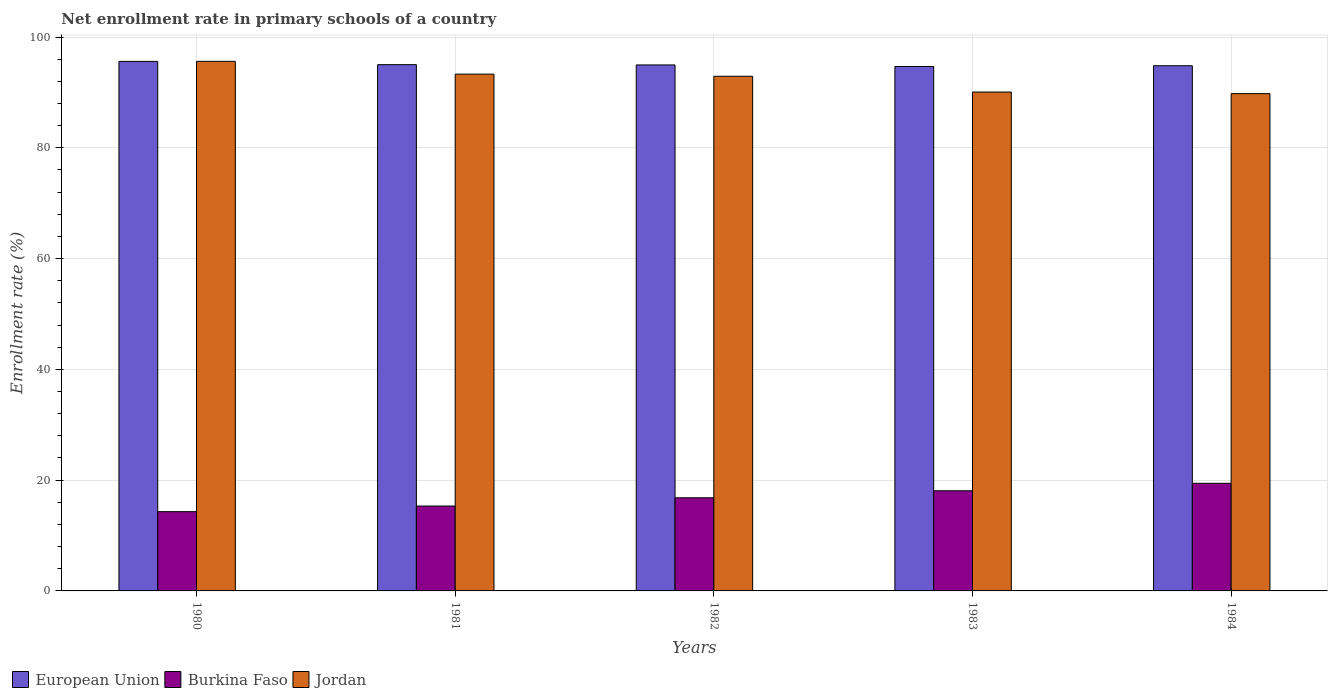How many groups of bars are there?
Give a very brief answer. 5. Are the number of bars per tick equal to the number of legend labels?
Your response must be concise. Yes. What is the label of the 2nd group of bars from the left?
Your answer should be compact. 1981. What is the enrollment rate in primary schools in European Union in 1982?
Provide a short and direct response. 94.96. Across all years, what is the maximum enrollment rate in primary schools in Burkina Faso?
Keep it short and to the point. 19.43. Across all years, what is the minimum enrollment rate in primary schools in Burkina Faso?
Give a very brief answer. 14.31. What is the total enrollment rate in primary schools in European Union in the graph?
Give a very brief answer. 475.05. What is the difference between the enrollment rate in primary schools in Jordan in 1981 and that in 1983?
Give a very brief answer. 3.23. What is the difference between the enrollment rate in primary schools in European Union in 1983 and the enrollment rate in primary schools in Jordan in 1980?
Offer a terse response. -0.93. What is the average enrollment rate in primary schools in Jordan per year?
Offer a very short reply. 92.33. In the year 1983, what is the difference between the enrollment rate in primary schools in European Union and enrollment rate in primary schools in Jordan?
Your answer should be compact. 4.61. What is the ratio of the enrollment rate in primary schools in Burkina Faso in 1981 to that in 1983?
Provide a succinct answer. 0.85. Is the difference between the enrollment rate in primary schools in European Union in 1982 and 1983 greater than the difference between the enrollment rate in primary schools in Jordan in 1982 and 1983?
Offer a terse response. No. What is the difference between the highest and the second highest enrollment rate in primary schools in European Union?
Keep it short and to the point. 0.59. What is the difference between the highest and the lowest enrollment rate in primary schools in Burkina Faso?
Your answer should be very brief. 5.12. In how many years, is the enrollment rate in primary schools in Jordan greater than the average enrollment rate in primary schools in Jordan taken over all years?
Offer a terse response. 3. What does the 3rd bar from the left in 1983 represents?
Provide a short and direct response. Jordan. What does the 1st bar from the right in 1982 represents?
Make the answer very short. Jordan. How many bars are there?
Offer a very short reply. 15. Are all the bars in the graph horizontal?
Keep it short and to the point. No. How many years are there in the graph?
Keep it short and to the point. 5. What is the difference between two consecutive major ticks on the Y-axis?
Offer a terse response. 20. Does the graph contain any zero values?
Offer a very short reply. No. Does the graph contain grids?
Your answer should be compact. Yes. How are the legend labels stacked?
Make the answer very short. Horizontal. What is the title of the graph?
Your answer should be compact. Net enrollment rate in primary schools of a country. Does "Iceland" appear as one of the legend labels in the graph?
Ensure brevity in your answer.  No. What is the label or title of the X-axis?
Ensure brevity in your answer.  Years. What is the label or title of the Y-axis?
Provide a short and direct response. Enrollment rate (%). What is the Enrollment rate (%) in European Union in 1980?
Ensure brevity in your answer.  95.6. What is the Enrollment rate (%) of Burkina Faso in 1980?
Your answer should be compact. 14.31. What is the Enrollment rate (%) in Jordan in 1980?
Your answer should be compact. 95.61. What is the Enrollment rate (%) in European Union in 1981?
Give a very brief answer. 95.01. What is the Enrollment rate (%) in Burkina Faso in 1981?
Ensure brevity in your answer.  15.32. What is the Enrollment rate (%) in Jordan in 1981?
Ensure brevity in your answer.  93.3. What is the Enrollment rate (%) in European Union in 1982?
Offer a terse response. 94.96. What is the Enrollment rate (%) of Burkina Faso in 1982?
Keep it short and to the point. 16.81. What is the Enrollment rate (%) in Jordan in 1982?
Your response must be concise. 92.91. What is the Enrollment rate (%) in European Union in 1983?
Provide a short and direct response. 94.67. What is the Enrollment rate (%) of Burkina Faso in 1983?
Your response must be concise. 18.08. What is the Enrollment rate (%) in Jordan in 1983?
Give a very brief answer. 90.07. What is the Enrollment rate (%) of European Union in 1984?
Provide a short and direct response. 94.81. What is the Enrollment rate (%) of Burkina Faso in 1984?
Offer a terse response. 19.43. What is the Enrollment rate (%) of Jordan in 1984?
Your answer should be compact. 89.78. Across all years, what is the maximum Enrollment rate (%) of European Union?
Provide a succinct answer. 95.6. Across all years, what is the maximum Enrollment rate (%) in Burkina Faso?
Provide a succinct answer. 19.43. Across all years, what is the maximum Enrollment rate (%) of Jordan?
Make the answer very short. 95.61. Across all years, what is the minimum Enrollment rate (%) of European Union?
Offer a terse response. 94.67. Across all years, what is the minimum Enrollment rate (%) in Burkina Faso?
Keep it short and to the point. 14.31. Across all years, what is the minimum Enrollment rate (%) in Jordan?
Offer a very short reply. 89.78. What is the total Enrollment rate (%) in European Union in the graph?
Provide a succinct answer. 475.05. What is the total Enrollment rate (%) of Burkina Faso in the graph?
Make the answer very short. 83.96. What is the total Enrollment rate (%) in Jordan in the graph?
Provide a short and direct response. 461.66. What is the difference between the Enrollment rate (%) of European Union in 1980 and that in 1981?
Your response must be concise. 0.59. What is the difference between the Enrollment rate (%) of Burkina Faso in 1980 and that in 1981?
Keep it short and to the point. -1.02. What is the difference between the Enrollment rate (%) of Jordan in 1980 and that in 1981?
Offer a terse response. 2.31. What is the difference between the Enrollment rate (%) in European Union in 1980 and that in 1982?
Your answer should be compact. 0.64. What is the difference between the Enrollment rate (%) in Burkina Faso in 1980 and that in 1982?
Your answer should be compact. -2.51. What is the difference between the Enrollment rate (%) of Jordan in 1980 and that in 1982?
Give a very brief answer. 2.69. What is the difference between the Enrollment rate (%) in European Union in 1980 and that in 1983?
Ensure brevity in your answer.  0.93. What is the difference between the Enrollment rate (%) of Burkina Faso in 1980 and that in 1983?
Make the answer very short. -3.77. What is the difference between the Enrollment rate (%) of Jordan in 1980 and that in 1983?
Offer a very short reply. 5.54. What is the difference between the Enrollment rate (%) of European Union in 1980 and that in 1984?
Provide a succinct answer. 0.79. What is the difference between the Enrollment rate (%) in Burkina Faso in 1980 and that in 1984?
Offer a very short reply. -5.12. What is the difference between the Enrollment rate (%) of Jordan in 1980 and that in 1984?
Give a very brief answer. 5.82. What is the difference between the Enrollment rate (%) in European Union in 1981 and that in 1982?
Offer a very short reply. 0.05. What is the difference between the Enrollment rate (%) of Burkina Faso in 1981 and that in 1982?
Keep it short and to the point. -1.49. What is the difference between the Enrollment rate (%) in Jordan in 1981 and that in 1982?
Give a very brief answer. 0.39. What is the difference between the Enrollment rate (%) in European Union in 1981 and that in 1983?
Make the answer very short. 0.33. What is the difference between the Enrollment rate (%) in Burkina Faso in 1981 and that in 1983?
Provide a succinct answer. -2.76. What is the difference between the Enrollment rate (%) in Jordan in 1981 and that in 1983?
Offer a very short reply. 3.23. What is the difference between the Enrollment rate (%) of European Union in 1981 and that in 1984?
Offer a terse response. 0.19. What is the difference between the Enrollment rate (%) in Burkina Faso in 1981 and that in 1984?
Keep it short and to the point. -4.1. What is the difference between the Enrollment rate (%) of Jordan in 1981 and that in 1984?
Offer a very short reply. 3.52. What is the difference between the Enrollment rate (%) of European Union in 1982 and that in 1983?
Offer a terse response. 0.28. What is the difference between the Enrollment rate (%) of Burkina Faso in 1982 and that in 1983?
Offer a very short reply. -1.27. What is the difference between the Enrollment rate (%) in Jordan in 1982 and that in 1983?
Keep it short and to the point. 2.85. What is the difference between the Enrollment rate (%) of European Union in 1982 and that in 1984?
Provide a succinct answer. 0.14. What is the difference between the Enrollment rate (%) in Burkina Faso in 1982 and that in 1984?
Make the answer very short. -2.62. What is the difference between the Enrollment rate (%) of Jordan in 1982 and that in 1984?
Make the answer very short. 3.13. What is the difference between the Enrollment rate (%) in European Union in 1983 and that in 1984?
Offer a very short reply. -0.14. What is the difference between the Enrollment rate (%) in Burkina Faso in 1983 and that in 1984?
Your answer should be very brief. -1.35. What is the difference between the Enrollment rate (%) in Jordan in 1983 and that in 1984?
Make the answer very short. 0.28. What is the difference between the Enrollment rate (%) of European Union in 1980 and the Enrollment rate (%) of Burkina Faso in 1981?
Offer a very short reply. 80.28. What is the difference between the Enrollment rate (%) of European Union in 1980 and the Enrollment rate (%) of Jordan in 1981?
Ensure brevity in your answer.  2.3. What is the difference between the Enrollment rate (%) in Burkina Faso in 1980 and the Enrollment rate (%) in Jordan in 1981?
Ensure brevity in your answer.  -78.99. What is the difference between the Enrollment rate (%) of European Union in 1980 and the Enrollment rate (%) of Burkina Faso in 1982?
Ensure brevity in your answer.  78.79. What is the difference between the Enrollment rate (%) of European Union in 1980 and the Enrollment rate (%) of Jordan in 1982?
Provide a short and direct response. 2.69. What is the difference between the Enrollment rate (%) of Burkina Faso in 1980 and the Enrollment rate (%) of Jordan in 1982?
Provide a short and direct response. -78.6. What is the difference between the Enrollment rate (%) in European Union in 1980 and the Enrollment rate (%) in Burkina Faso in 1983?
Your answer should be very brief. 77.52. What is the difference between the Enrollment rate (%) in European Union in 1980 and the Enrollment rate (%) in Jordan in 1983?
Give a very brief answer. 5.54. What is the difference between the Enrollment rate (%) of Burkina Faso in 1980 and the Enrollment rate (%) of Jordan in 1983?
Offer a terse response. -75.76. What is the difference between the Enrollment rate (%) in European Union in 1980 and the Enrollment rate (%) in Burkina Faso in 1984?
Provide a succinct answer. 76.17. What is the difference between the Enrollment rate (%) of European Union in 1980 and the Enrollment rate (%) of Jordan in 1984?
Provide a succinct answer. 5.82. What is the difference between the Enrollment rate (%) of Burkina Faso in 1980 and the Enrollment rate (%) of Jordan in 1984?
Your answer should be very brief. -75.47. What is the difference between the Enrollment rate (%) in European Union in 1981 and the Enrollment rate (%) in Burkina Faso in 1982?
Offer a very short reply. 78.19. What is the difference between the Enrollment rate (%) of European Union in 1981 and the Enrollment rate (%) of Jordan in 1982?
Offer a terse response. 2.09. What is the difference between the Enrollment rate (%) of Burkina Faso in 1981 and the Enrollment rate (%) of Jordan in 1982?
Provide a succinct answer. -77.59. What is the difference between the Enrollment rate (%) of European Union in 1981 and the Enrollment rate (%) of Burkina Faso in 1983?
Your answer should be very brief. 76.93. What is the difference between the Enrollment rate (%) in European Union in 1981 and the Enrollment rate (%) in Jordan in 1983?
Your answer should be very brief. 4.94. What is the difference between the Enrollment rate (%) of Burkina Faso in 1981 and the Enrollment rate (%) of Jordan in 1983?
Provide a short and direct response. -74.74. What is the difference between the Enrollment rate (%) in European Union in 1981 and the Enrollment rate (%) in Burkina Faso in 1984?
Your answer should be very brief. 75.58. What is the difference between the Enrollment rate (%) in European Union in 1981 and the Enrollment rate (%) in Jordan in 1984?
Your answer should be very brief. 5.23. What is the difference between the Enrollment rate (%) in Burkina Faso in 1981 and the Enrollment rate (%) in Jordan in 1984?
Keep it short and to the point. -74.46. What is the difference between the Enrollment rate (%) in European Union in 1982 and the Enrollment rate (%) in Burkina Faso in 1983?
Ensure brevity in your answer.  76.88. What is the difference between the Enrollment rate (%) of European Union in 1982 and the Enrollment rate (%) of Jordan in 1983?
Keep it short and to the point. 4.89. What is the difference between the Enrollment rate (%) in Burkina Faso in 1982 and the Enrollment rate (%) in Jordan in 1983?
Provide a succinct answer. -73.25. What is the difference between the Enrollment rate (%) in European Union in 1982 and the Enrollment rate (%) in Burkina Faso in 1984?
Provide a short and direct response. 75.53. What is the difference between the Enrollment rate (%) in European Union in 1982 and the Enrollment rate (%) in Jordan in 1984?
Keep it short and to the point. 5.18. What is the difference between the Enrollment rate (%) of Burkina Faso in 1982 and the Enrollment rate (%) of Jordan in 1984?
Your answer should be very brief. -72.97. What is the difference between the Enrollment rate (%) in European Union in 1983 and the Enrollment rate (%) in Burkina Faso in 1984?
Keep it short and to the point. 75.25. What is the difference between the Enrollment rate (%) in European Union in 1983 and the Enrollment rate (%) in Jordan in 1984?
Ensure brevity in your answer.  4.89. What is the difference between the Enrollment rate (%) of Burkina Faso in 1983 and the Enrollment rate (%) of Jordan in 1984?
Keep it short and to the point. -71.7. What is the average Enrollment rate (%) of European Union per year?
Your response must be concise. 95.01. What is the average Enrollment rate (%) in Burkina Faso per year?
Ensure brevity in your answer.  16.79. What is the average Enrollment rate (%) in Jordan per year?
Provide a succinct answer. 92.33. In the year 1980, what is the difference between the Enrollment rate (%) of European Union and Enrollment rate (%) of Burkina Faso?
Make the answer very short. 81.29. In the year 1980, what is the difference between the Enrollment rate (%) in European Union and Enrollment rate (%) in Jordan?
Offer a terse response. -0. In the year 1980, what is the difference between the Enrollment rate (%) of Burkina Faso and Enrollment rate (%) of Jordan?
Make the answer very short. -81.3. In the year 1981, what is the difference between the Enrollment rate (%) in European Union and Enrollment rate (%) in Burkina Faso?
Offer a terse response. 79.68. In the year 1981, what is the difference between the Enrollment rate (%) in European Union and Enrollment rate (%) in Jordan?
Your answer should be compact. 1.71. In the year 1981, what is the difference between the Enrollment rate (%) of Burkina Faso and Enrollment rate (%) of Jordan?
Provide a short and direct response. -77.97. In the year 1982, what is the difference between the Enrollment rate (%) of European Union and Enrollment rate (%) of Burkina Faso?
Ensure brevity in your answer.  78.14. In the year 1982, what is the difference between the Enrollment rate (%) of European Union and Enrollment rate (%) of Jordan?
Keep it short and to the point. 2.05. In the year 1982, what is the difference between the Enrollment rate (%) of Burkina Faso and Enrollment rate (%) of Jordan?
Keep it short and to the point. -76.1. In the year 1983, what is the difference between the Enrollment rate (%) of European Union and Enrollment rate (%) of Burkina Faso?
Ensure brevity in your answer.  76.59. In the year 1983, what is the difference between the Enrollment rate (%) of European Union and Enrollment rate (%) of Jordan?
Provide a succinct answer. 4.61. In the year 1983, what is the difference between the Enrollment rate (%) of Burkina Faso and Enrollment rate (%) of Jordan?
Provide a short and direct response. -71.99. In the year 1984, what is the difference between the Enrollment rate (%) of European Union and Enrollment rate (%) of Burkina Faso?
Make the answer very short. 75.38. In the year 1984, what is the difference between the Enrollment rate (%) in European Union and Enrollment rate (%) in Jordan?
Keep it short and to the point. 5.03. In the year 1984, what is the difference between the Enrollment rate (%) in Burkina Faso and Enrollment rate (%) in Jordan?
Your response must be concise. -70.35. What is the ratio of the Enrollment rate (%) of European Union in 1980 to that in 1981?
Give a very brief answer. 1.01. What is the ratio of the Enrollment rate (%) in Burkina Faso in 1980 to that in 1981?
Keep it short and to the point. 0.93. What is the ratio of the Enrollment rate (%) of Jordan in 1980 to that in 1981?
Ensure brevity in your answer.  1.02. What is the ratio of the Enrollment rate (%) of European Union in 1980 to that in 1982?
Provide a succinct answer. 1.01. What is the ratio of the Enrollment rate (%) in Burkina Faso in 1980 to that in 1982?
Your answer should be compact. 0.85. What is the ratio of the Enrollment rate (%) of Jordan in 1980 to that in 1982?
Provide a short and direct response. 1.03. What is the ratio of the Enrollment rate (%) of European Union in 1980 to that in 1983?
Provide a succinct answer. 1.01. What is the ratio of the Enrollment rate (%) of Burkina Faso in 1980 to that in 1983?
Your answer should be compact. 0.79. What is the ratio of the Enrollment rate (%) in Jordan in 1980 to that in 1983?
Offer a very short reply. 1.06. What is the ratio of the Enrollment rate (%) in European Union in 1980 to that in 1984?
Offer a very short reply. 1.01. What is the ratio of the Enrollment rate (%) of Burkina Faso in 1980 to that in 1984?
Offer a very short reply. 0.74. What is the ratio of the Enrollment rate (%) of Jordan in 1980 to that in 1984?
Ensure brevity in your answer.  1.06. What is the ratio of the Enrollment rate (%) in European Union in 1981 to that in 1982?
Provide a succinct answer. 1. What is the ratio of the Enrollment rate (%) of Burkina Faso in 1981 to that in 1982?
Provide a short and direct response. 0.91. What is the ratio of the Enrollment rate (%) of European Union in 1981 to that in 1983?
Provide a succinct answer. 1. What is the ratio of the Enrollment rate (%) of Burkina Faso in 1981 to that in 1983?
Offer a very short reply. 0.85. What is the ratio of the Enrollment rate (%) of Jordan in 1981 to that in 1983?
Provide a short and direct response. 1.04. What is the ratio of the Enrollment rate (%) of Burkina Faso in 1981 to that in 1984?
Ensure brevity in your answer.  0.79. What is the ratio of the Enrollment rate (%) of Jordan in 1981 to that in 1984?
Provide a succinct answer. 1.04. What is the ratio of the Enrollment rate (%) of Burkina Faso in 1982 to that in 1983?
Offer a very short reply. 0.93. What is the ratio of the Enrollment rate (%) in Jordan in 1982 to that in 1983?
Make the answer very short. 1.03. What is the ratio of the Enrollment rate (%) of European Union in 1982 to that in 1984?
Provide a short and direct response. 1. What is the ratio of the Enrollment rate (%) of Burkina Faso in 1982 to that in 1984?
Give a very brief answer. 0.87. What is the ratio of the Enrollment rate (%) in Jordan in 1982 to that in 1984?
Your answer should be very brief. 1.03. What is the ratio of the Enrollment rate (%) of European Union in 1983 to that in 1984?
Provide a succinct answer. 1. What is the ratio of the Enrollment rate (%) of Burkina Faso in 1983 to that in 1984?
Ensure brevity in your answer.  0.93. What is the difference between the highest and the second highest Enrollment rate (%) of European Union?
Offer a very short reply. 0.59. What is the difference between the highest and the second highest Enrollment rate (%) of Burkina Faso?
Keep it short and to the point. 1.35. What is the difference between the highest and the second highest Enrollment rate (%) of Jordan?
Your answer should be very brief. 2.31. What is the difference between the highest and the lowest Enrollment rate (%) in European Union?
Give a very brief answer. 0.93. What is the difference between the highest and the lowest Enrollment rate (%) in Burkina Faso?
Give a very brief answer. 5.12. What is the difference between the highest and the lowest Enrollment rate (%) in Jordan?
Keep it short and to the point. 5.82. 